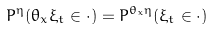Convert formula to latex. <formula><loc_0><loc_0><loc_500><loc_500>P ^ { \eta } ( \theta _ { x } \xi _ { t } \in \cdot ) = P ^ { \theta _ { x } \eta } ( \xi _ { t } \in \cdot )</formula> 